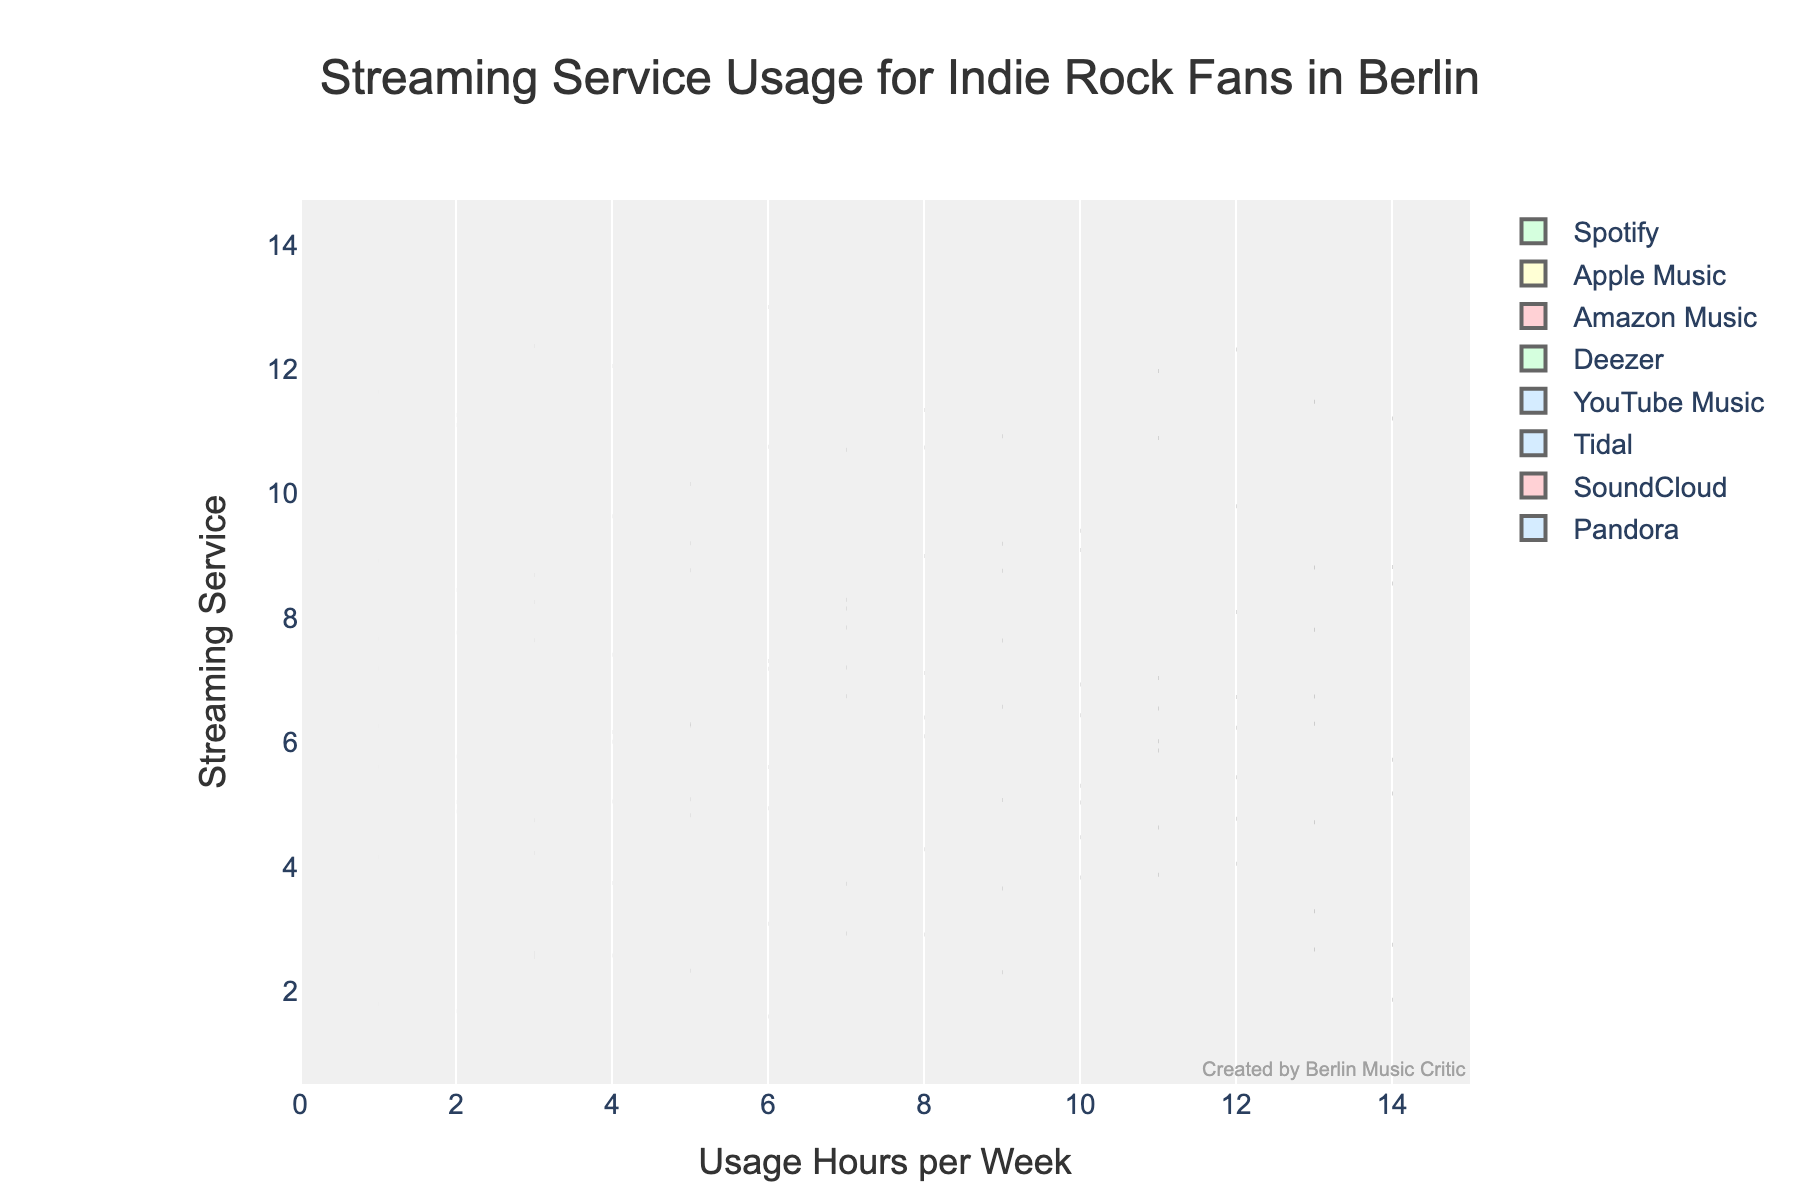What's the title of the figure? The title of a plot is usually found at the top of the figure, providing an overview of the displayed data. In this case, the title indicates the focus of the figure.
Answer: Streaming Service Usage for Indie Rock Fans in Berlin What does the x-axis represent? The x-axis label usually indicates what the axis measures. Here, it's labeled 'Usage Hours per Week,' telling us that it measures the number of hours per week indie rock fans use streaming services.
Answer: Usage Hours per Week Which streaming service shows the highest median usage hours per week? In a violin plot, the median is often indicated by a horizontal line inside the box plot. By comparing these medians, we can find the highest one.
Answer: Spotify What is the range of the x-axis? The range of the x-axis is set by the axis limits shown in the figure. Here, it limits the axis from 0 to 15 usage hours per week.
Answer: 0 to 15 How do the mean usage hours of Spotify and Tidal compare? The mean usage hours are shown by the position of the meanline in each violin plot. By comparing the positions for Spotify and Tidal, we can see which one is higher.
Answer: Spotify has higher mean usage hours than Tidal Which streaming service has the lowest maximum usage hours? The maximum usage hours for each streaming service are visible at the top end of the shaded area in each violin plot. By comparing these, we can find the lowest one.
Answer: Tidal What's the difference between the highest and lowest median usage hours per week? First, identify the highest and lowest medians from the violin plots. The highest median is from Spotify (12 hours), and the lowest median is from Tidal (3 hours). Subtract the lowest from the highest to get the difference.
Answer: 9 hours Which streaming service has the most spread in usage hours per week? The spread can be seen by looking at the width of each violin plot. The wider the plot, the more spread out the data is.
Answer: Spotify If a user listens to Amazon Music for 6 hours per week, how does their usage compare to the median usage for Amazon Music users? By identifying the median usage for Amazon Music on the violin plot and comparing the user's 6 hours to this median, we can determine if it's above, below, or equal.
Answer: The user's usage is higher than the median 